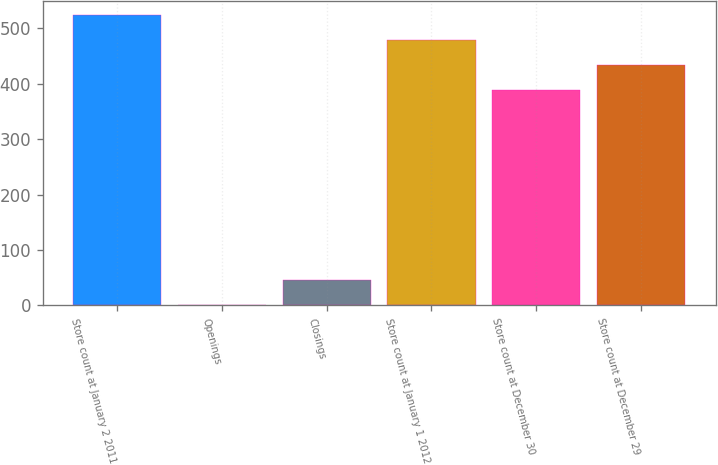Convert chart. <chart><loc_0><loc_0><loc_500><loc_500><bar_chart><fcel>Store count at January 2 2011<fcel>Openings<fcel>Closings<fcel>Store count at January 1 2012<fcel>Store count at December 30<fcel>Store count at December 29<nl><fcel>523.9<fcel>1<fcel>46.3<fcel>478.6<fcel>388<fcel>433.3<nl></chart> 